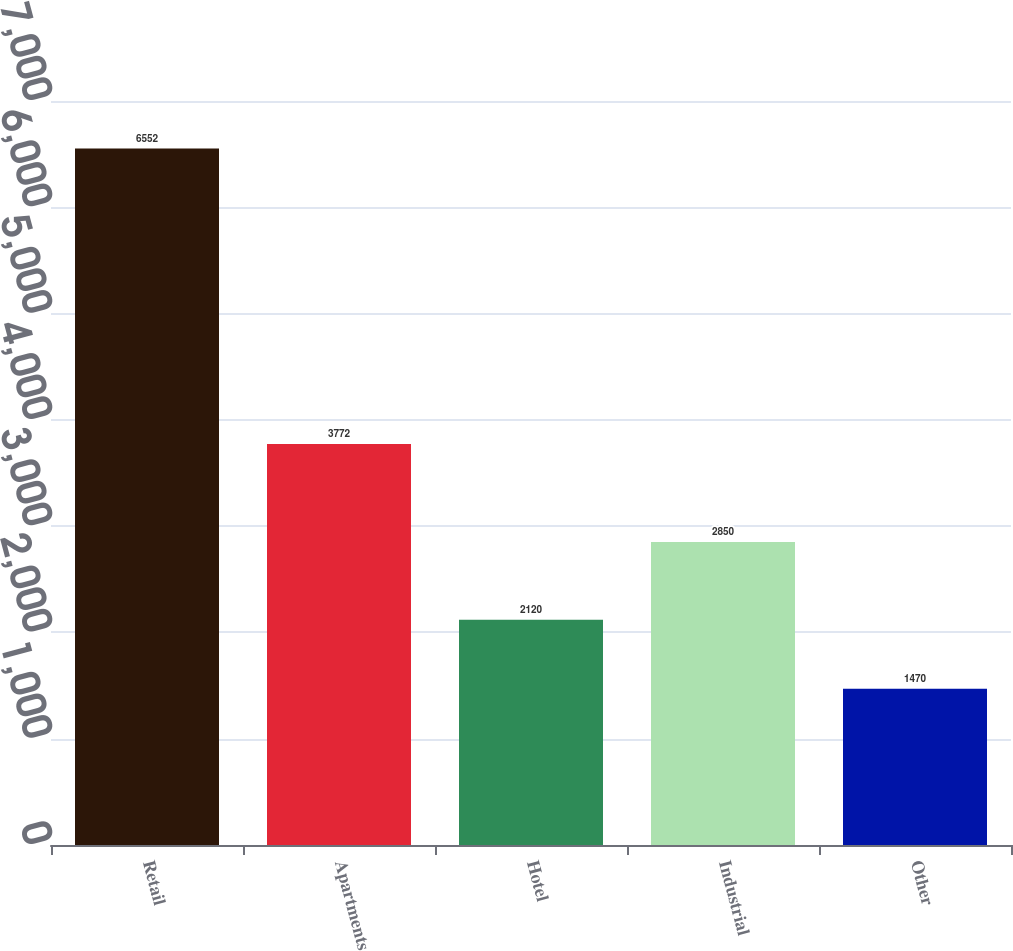Convert chart. <chart><loc_0><loc_0><loc_500><loc_500><bar_chart><fcel>Retail<fcel>Apartments<fcel>Hotel<fcel>Industrial<fcel>Other<nl><fcel>6552<fcel>3772<fcel>2120<fcel>2850<fcel>1470<nl></chart> 